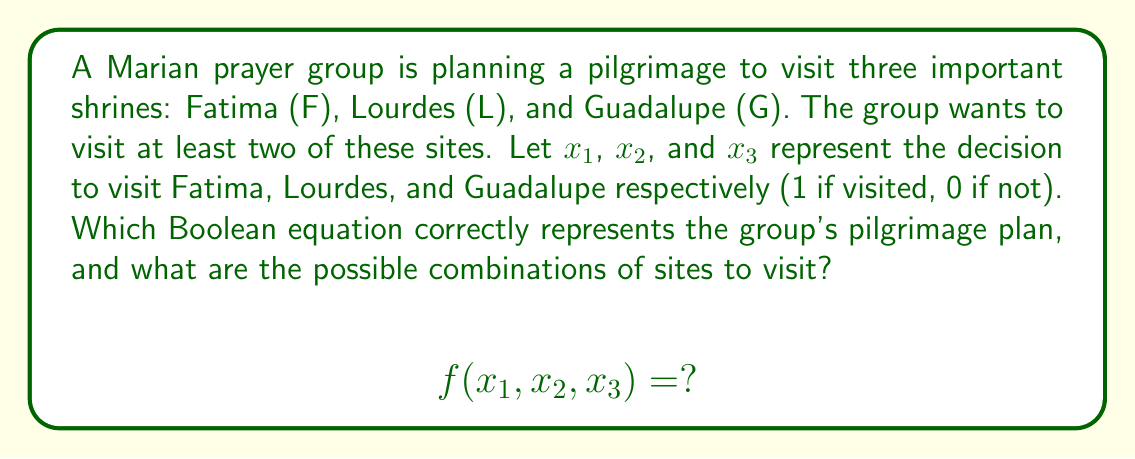Help me with this question. To solve this problem, we need to follow these steps:

1) First, we need to understand what the question is asking. We want a Boolean equation that represents visiting at least two out of three sites.

2) The Boolean equation should be true (1) when two or more variables are 1, and false (0) otherwise.

3) We can represent this using the following Boolean equation:

   $$f(x_1, x_2, x_3) = x_1x_2 + x_1x_3 + x_2x_3$$

   This equation is true when at least two variables are 1.

4) To find the possible combinations, we need to evaluate this function for all possible inputs:

   $f(0,0,0) = 0$ (Not valid - no sites visited)
   $f(0,0,1) = f(0,1,0) = f(1,0,0) = 0$ (Not valid - only one site visited)
   $f(0,1,1) = f(1,0,1) = f(1,1,0) = 1$ (Valid - two sites visited)
   $f(1,1,1) = 1$ (Valid - all three sites visited)

5) Therefore, the valid combinations are:
   - Fatima and Lourdes (1,1,0)
   - Fatima and Guadalupe (1,0,1)
   - Lourdes and Guadalupe (0,1,1)
   - All three sites (1,1,1)
Answer: $$f(x_1, x_2, x_3) = x_1x_2 + x_1x_3 + x_2x_3$$
Valid combinations: (1,1,0), (1,0,1), (0,1,1), (1,1,1) 